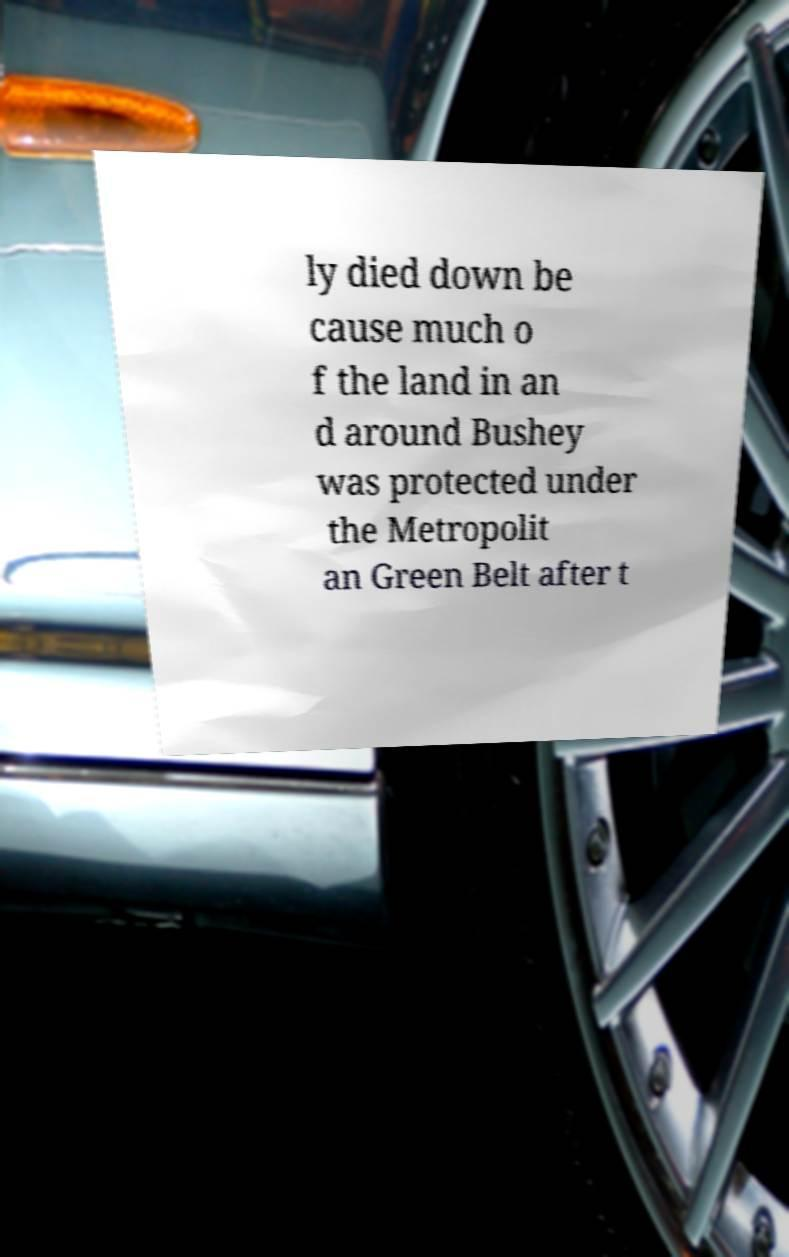I need the written content from this picture converted into text. Can you do that? ly died down be cause much o f the land in an d around Bushey was protected under the Metropolit an Green Belt after t 